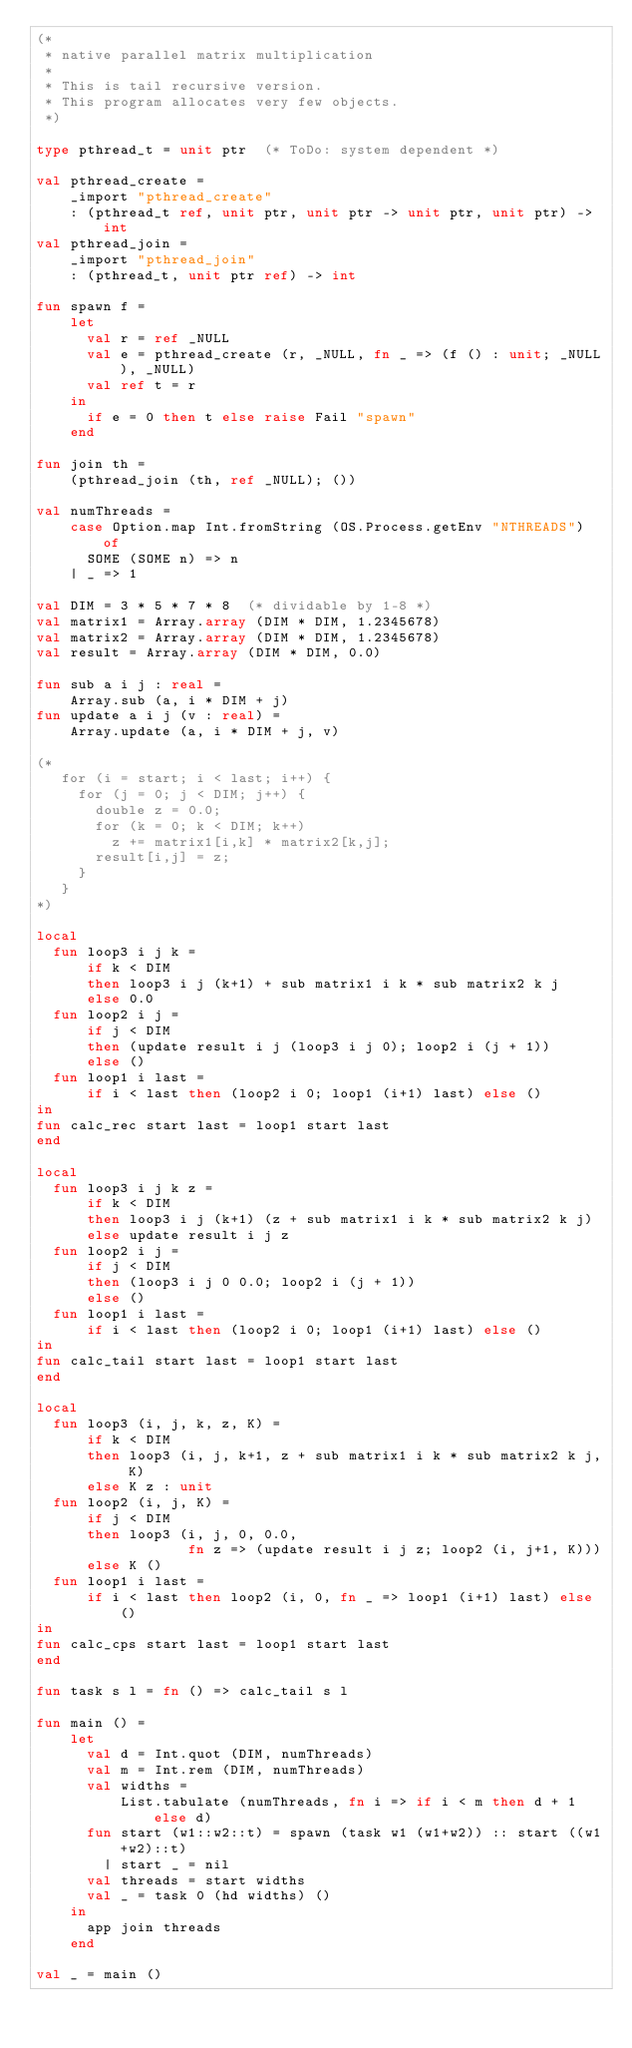Convert code to text. <code><loc_0><loc_0><loc_500><loc_500><_SML_>(*
 * native parallel matrix multiplication
 *
 * This is tail recursive version.
 * This program allocates very few objects.
 *)

type pthread_t = unit ptr  (* ToDo: system dependent *)

val pthread_create =
    _import "pthread_create"
    : (pthread_t ref, unit ptr, unit ptr -> unit ptr, unit ptr) -> int
val pthread_join =
    _import "pthread_join"
    : (pthread_t, unit ptr ref) -> int

fun spawn f =
    let
      val r = ref _NULL
      val e = pthread_create (r, _NULL, fn _ => (f () : unit; _NULL), _NULL)
      val ref t = r
    in
      if e = 0 then t else raise Fail "spawn"
    end

fun join th =
    (pthread_join (th, ref _NULL); ())

val numThreads =
    case Option.map Int.fromString (OS.Process.getEnv "NTHREADS") of
      SOME (SOME n) => n
    | _ => 1

val DIM = 3 * 5 * 7 * 8  (* dividable by 1-8 *)
val matrix1 = Array.array (DIM * DIM, 1.2345678)
val matrix2 = Array.array (DIM * DIM, 1.2345678)
val result = Array.array (DIM * DIM, 0.0)

fun sub a i j : real =
    Array.sub (a, i * DIM + j)
fun update a i j (v : real) =
    Array.update (a, i * DIM + j, v)

(*
   for (i = start; i < last; i++) {
     for (j = 0; j < DIM; j++) {
       double z = 0.0;
       for (k = 0; k < DIM; k++)
         z += matrix1[i,k] * matrix2[k,j];
       result[i,j] = z;
     }
   }
*)

local
  fun loop3 i j k =
      if k < DIM
      then loop3 i j (k+1) + sub matrix1 i k * sub matrix2 k j
      else 0.0
  fun loop2 i j =
      if j < DIM
      then (update result i j (loop3 i j 0); loop2 i (j + 1))
      else ()
  fun loop1 i last =
      if i < last then (loop2 i 0; loop1 (i+1) last) else ()
in
fun calc_rec start last = loop1 start last
end

local
  fun loop3 i j k z =
      if k < DIM
      then loop3 i j (k+1) (z + sub matrix1 i k * sub matrix2 k j)
      else update result i j z
  fun loop2 i j =
      if j < DIM
      then (loop3 i j 0 0.0; loop2 i (j + 1))
      else ()
  fun loop1 i last =
      if i < last then (loop2 i 0; loop1 (i+1) last) else ()
in
fun calc_tail start last = loop1 start last
end

local
  fun loop3 (i, j, k, z, K) =
      if k < DIM
      then loop3 (i, j, k+1, z + sub matrix1 i k * sub matrix2 k j, K)
      else K z : unit
  fun loop2 (i, j, K) =
      if j < DIM
      then loop3 (i, j, 0, 0.0,
                  fn z => (update result i j z; loop2 (i, j+1, K)))
      else K ()
  fun loop1 i last =
      if i < last then loop2 (i, 0, fn _ => loop1 (i+1) last) else ()
in
fun calc_cps start last = loop1 start last
end

fun task s l = fn () => calc_tail s l

fun main () =
    let
      val d = Int.quot (DIM, numThreads)
      val m = Int.rem (DIM, numThreads)
      val widths =
          List.tabulate (numThreads, fn i => if i < m then d + 1 else d)
      fun start (w1::w2::t) = spawn (task w1 (w1+w2)) :: start ((w1+w2)::t)
        | start _ = nil
      val threads = start widths
      val _ = task 0 (hd widths) ()
    in
      app join threads
    end

val _ = main ()
</code> 